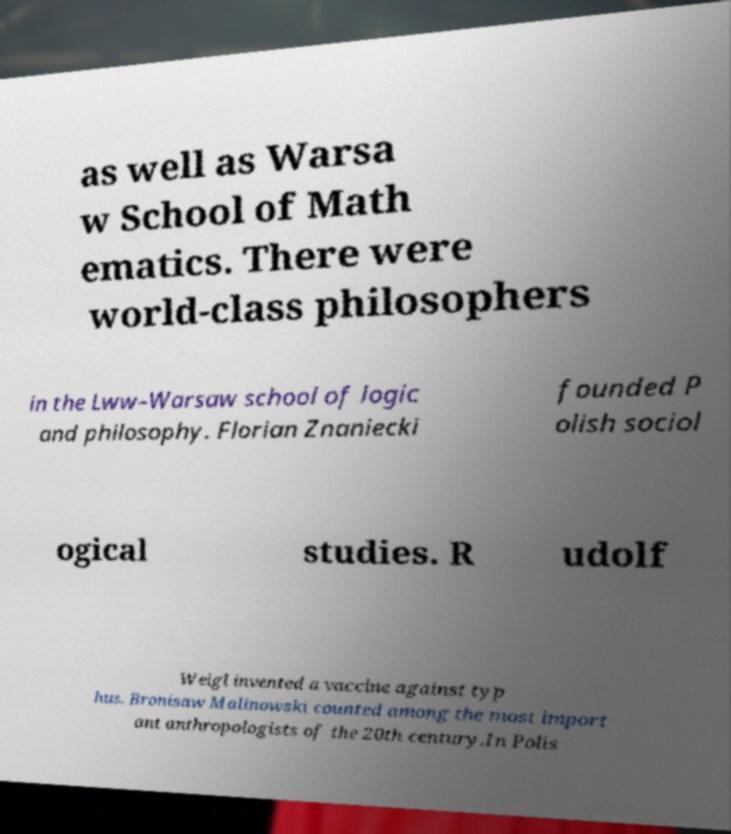Could you extract and type out the text from this image? as well as Warsa w School of Math ematics. There were world-class philosophers in the Lww–Warsaw school of logic and philosophy. Florian Znaniecki founded P olish sociol ogical studies. R udolf Weigl invented a vaccine against typ hus. Bronisaw Malinowski counted among the most import ant anthropologists of the 20th century.In Polis 